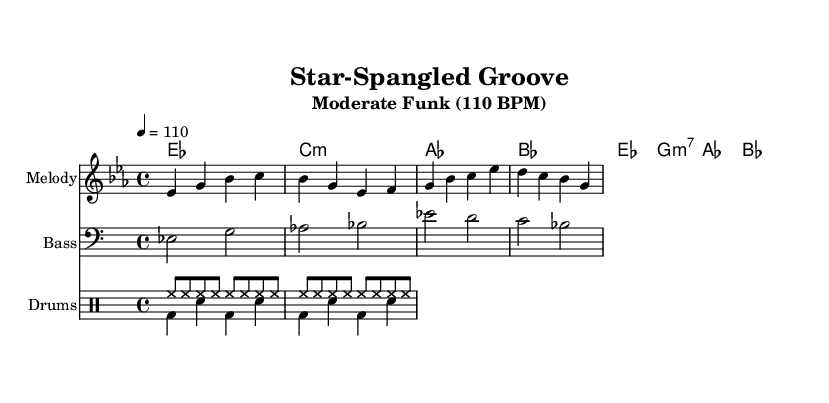What is the key signature of this music? The key signature indicated at the beginning of the sheet music is E flat major, which has three flats (B flat, E flat, and A flat).
Answer: E flat major What is the time signature of this piece? The time signature shown at the beginning of the score is 4/4, which means there are four beats in each measure and the quarter note receives one beat.
Answer: 4/4 What is the tempo of the song? The tempo is specified as 110 beats per minute, which sets the speed at which the piece should be played.
Answer: 110 BPM How many measures are there in the melody? By counting the distinct groups of notes separated by vertical lines, there are eight measures present in the melody part of the score.
Answer: 8 What type of drum pattern is used in this piece? The drum part consists of a hi-hat pattern with eighth notes on top and a bass-snare combination underneath. This is typical in funk and R&B styles.
Answer: Hi-hat and bass-snare What is the first lyric line of the song? The first line of the lyrics as noted directly above the melody indicates "Free -- dom's rhythm in our soul," which reflects the broader thematic celebration of American values.
Answer: Free -- dom's rhythm in our soul Which chord is played on the first measure? The first measure shows an E flat major chord, which is a major triad consisting of E flat, G, and B flat.
Answer: E flat major 